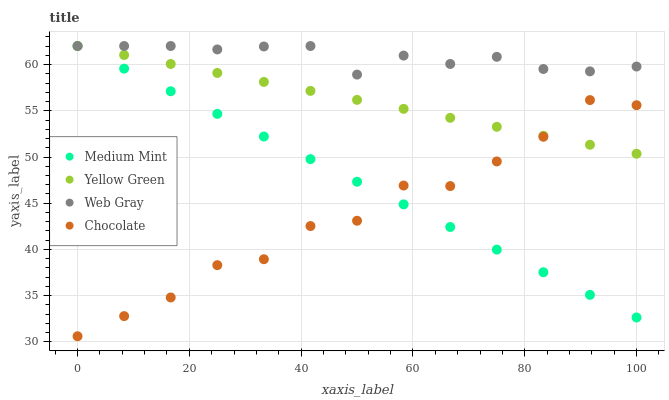Does Chocolate have the minimum area under the curve?
Answer yes or no. Yes. Does Web Gray have the maximum area under the curve?
Answer yes or no. Yes. Does Yellow Green have the minimum area under the curve?
Answer yes or no. No. Does Yellow Green have the maximum area under the curve?
Answer yes or no. No. Is Medium Mint the smoothest?
Answer yes or no. Yes. Is Chocolate the roughest?
Answer yes or no. Yes. Is Web Gray the smoothest?
Answer yes or no. No. Is Web Gray the roughest?
Answer yes or no. No. Does Chocolate have the lowest value?
Answer yes or no. Yes. Does Yellow Green have the lowest value?
Answer yes or no. No. Does Yellow Green have the highest value?
Answer yes or no. Yes. Does Chocolate have the highest value?
Answer yes or no. No. Is Chocolate less than Web Gray?
Answer yes or no. Yes. Is Web Gray greater than Chocolate?
Answer yes or no. Yes. Does Yellow Green intersect Web Gray?
Answer yes or no. Yes. Is Yellow Green less than Web Gray?
Answer yes or no. No. Is Yellow Green greater than Web Gray?
Answer yes or no. No. Does Chocolate intersect Web Gray?
Answer yes or no. No. 